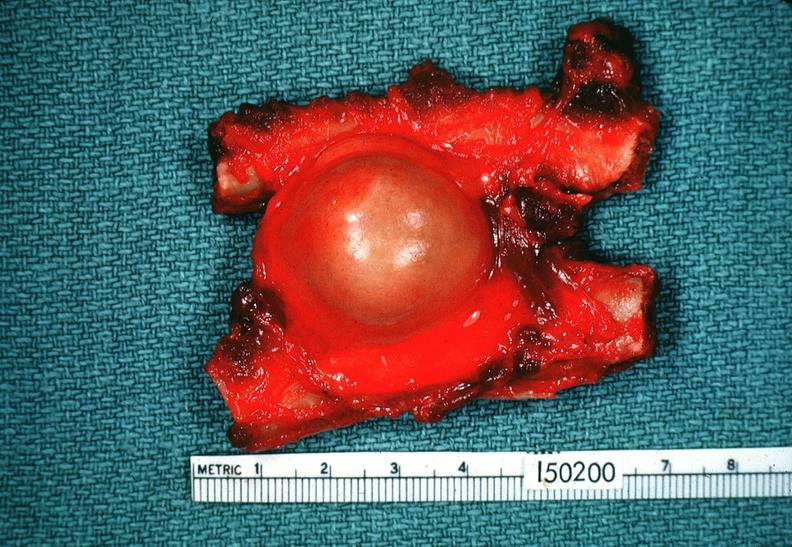s thyroid present?
Answer the question using a single word or phrase. No 